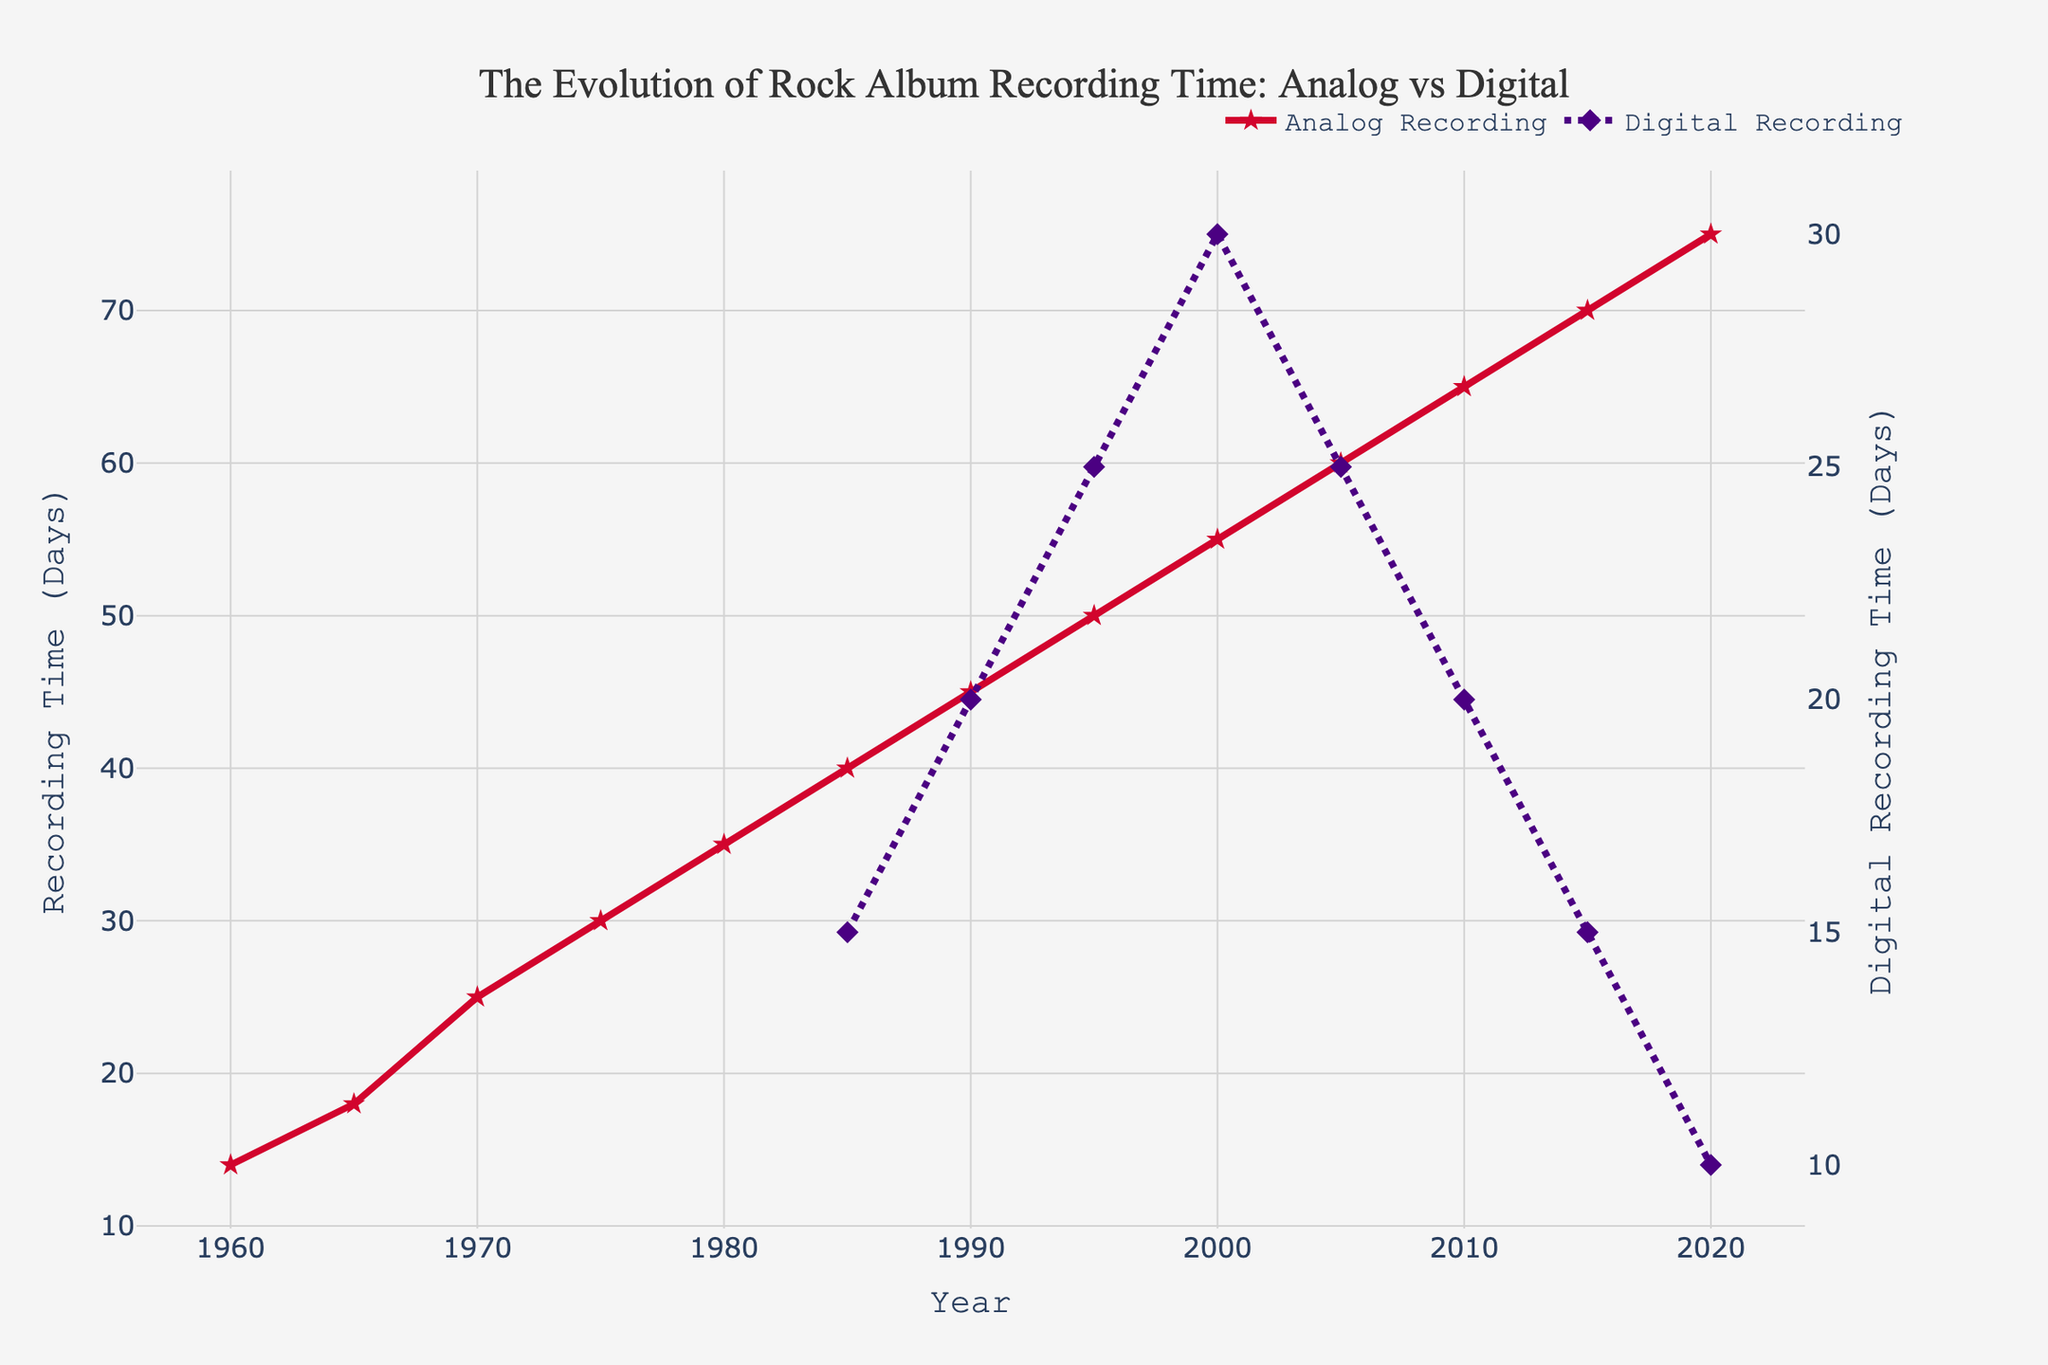What happens to the average analog recording time from 1960 to 2020? The analog recording time shows a steady increase from 14 days in 1960 to 75 days in 2020. As we move along the x-axis (Year), the line representing analog recording trends upwards consistently, indicating a rise.
Answer: It increases How does the digital recording time in 2020 compare to that in 1985? In 1985, the digital recording time was 15 days, and it decreased to 10 days by 2020. Comparing these two data points on the y-axis values, the digital recording time is less in 2020.
Answer: It decreases Which recording method required more time on average in 2005? The y-axis value for analog recording in 2005 is 60 days, whereas for digital recording, it is 25 days. The line representing analog recording is higher than the one representing digital in 2005.
Answer: Analog recording What is the difference in average recording time between analog and digital methods in 1995? In 1995, analog recording time is 50 days and digital recording time is 25 days. The difference is calculated as 50 - 25.
Answer: 25 days At what year did the digital recording time reach its peak, and what was that time? By observing the lines, digital recording time peaked in 2000 at 30 days. The peak is visually identifiable as the highest point on the digital line.
Answer: The year 2000, 30 days Does the analog recording time keep increasing consistently without any decreases? Yes, the line for analog recording continuously slopes upwards without any dips from 1960 to 2020. This indicates no decreases in recording time.
Answer: Yes What can you observe about the trend of digital recording time after its peak in 2000? After 2000, the digital recording time starts decreasing steadily from 30 days to 10 days by 2020. The line representing digital recording time shows a downward slope post-2000.
Answer: It decreases On average, which method showed a consistent increase in recording time from start to end? Analog recording time shows a consistent increase without any decrements from 1960 to 2020, as seen by its steadily rising line.
Answer: Analog recording How does the trend in analog recording time between 1990 and 2000 compare with that of digital recording time? From 1990 to 2000, analog recording time increases steadily from 45 days to 55 days, while digital recording time also increases from 20 days to 30 days. Both trends are upward during this period.
Answer: Both increase What is the total increase in analog recording time from 1960 to 2020? The analog recording time in 1960 is 14 days and reaches 75 days in 2020. The total increase is calculated as 75 - 14.
Answer: 61 days 